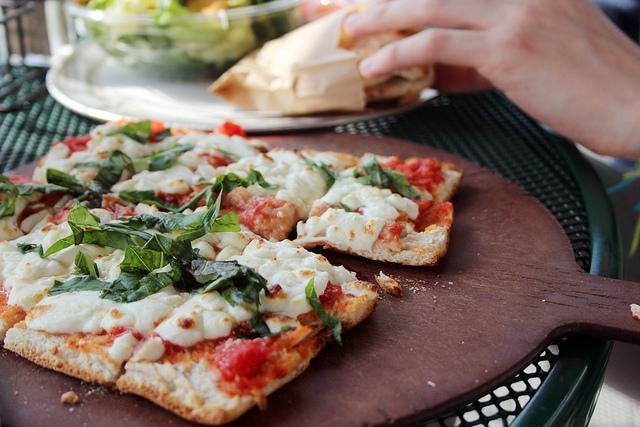Why is the pizza cut into small pieces?

Choices:
A) looks good
B) easier eating
C) to trash
D) see easier easier eating 